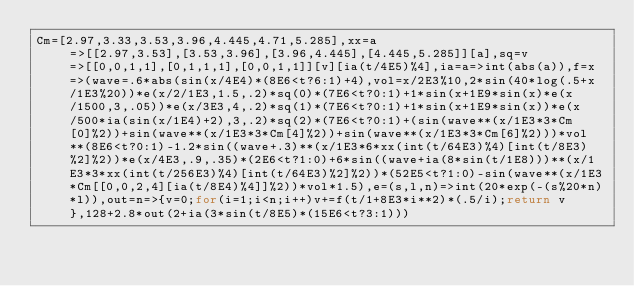<code> <loc_0><loc_0><loc_500><loc_500><_JavaScript_>Cm=[2.97,3.33,3.53,3.96,4.445,4.71,5.285],xx=a=>[[2.97,3.53],[3.53,3.96],[3.96,4.445],[4.445,5.285]][a],sq=v=>[[0,0,1,1],[0,1,1,1],[0,0,1,1]][v][ia(t/4E5)%4],ia=a=>int(abs(a)),f=x=>(wave=.6*abs(sin(x/4E4)*(8E6<t?6:1)+4),vol=x/2E3%10,2*sin(40*log(.5+x/1E3%20))*e(x/2/1E3,1.5,.2)*sq(0)*(7E6<t?0:1)+1*sin(x+1E9*sin(x)*e(x/1500,3,.05))*e(x/3E3,4,.2)*sq(1)*(7E6<t?0:1)+1*sin(x+1E9*sin(x))*e(x/500*ia(sin(x/1E4)+2),3,.2)*sq(2)*(7E6<t?0:1)+(sin(wave**(x/1E3*3*Cm[0]%2))+sin(wave**(x/1E3*3*Cm[4]%2))+sin(wave**(x/1E3*3*Cm[6]%2)))*vol**(8E6<t?0:1)-1.2*sin((wave+.3)**(x/1E3*6*xx(int(t/64E3)%4)[int(t/8E3)%2]%2))*e(x/4E3,.9,.35)*(2E6<t?1:0)+6*sin((wave+ia(8*sin(t/1E8)))**(x/1E3*3*xx(int(t/256E3)%4)[int(t/64E3)%2]%2))*(52E5<t?1:0)-sin(wave**(x/1E3*Cm[[0,0,2,4][ia(t/8E4)%4]]%2))*vol*1.5),e=(s,l,n)=>int(20*exp(-(s%20*n)*l)),out=n=>{v=0;for(i=1;i<n;i++)v+=f(t/1+8E3*i**2)*(.5/i);return v},128+2.8*out(2+ia(3*sin(t/8E5)*(15E6<t?3:1)))</code> 